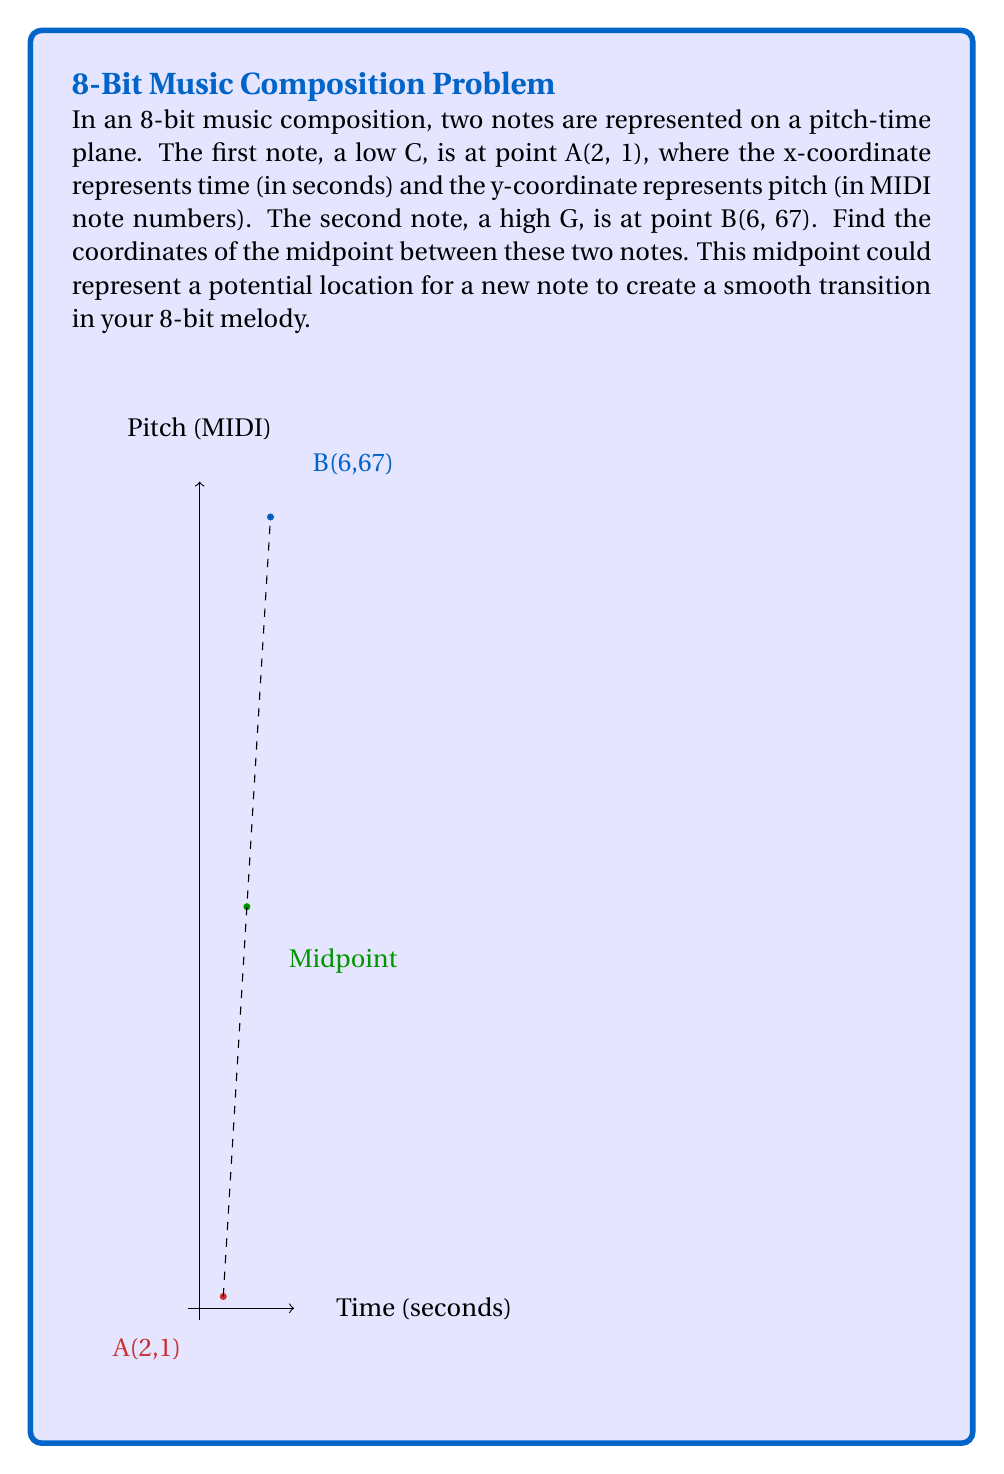Provide a solution to this math problem. To find the midpoint between two points in a coordinate system, we use the midpoint formula:

$$\text{Midpoint} = \left(\frac{x_1 + x_2}{2}, \frac{y_1 + y_2}{2}\right)$$

Where $(x_1, y_1)$ are the coordinates of the first point and $(x_2, y_2)$ are the coordinates of the second point.

Given:
- Point A (low C): $(2, 1)$
- Point B (high G): $(6, 67)$

Let's calculate the x-coordinate of the midpoint:
$$x = \frac{x_1 + x_2}{2} = \frac{2 + 6}{2} = \frac{8}{2} = 4$$

Now, let's calculate the y-coordinate of the midpoint:
$$y = \frac{y_1 + y_2}{2} = \frac{1 + 67}{2} = \frac{68}{2} = 34$$

Therefore, the midpoint between the two notes is $(4, 34)$.

In the context of 8-bit music composition, this midpoint represents a note that occurs 4 seconds into the composition (x-coordinate) with a MIDI pitch value of 34 (y-coordinate), which is approximately the note C#2 or Db2.
Answer: $(4, 34)$ 